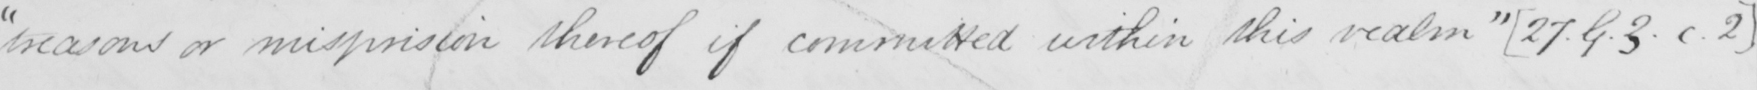Can you read and transcribe this handwriting? " treasons or misprision thereof if committed within this realm "   [ 27.G.3.c.2 ] 